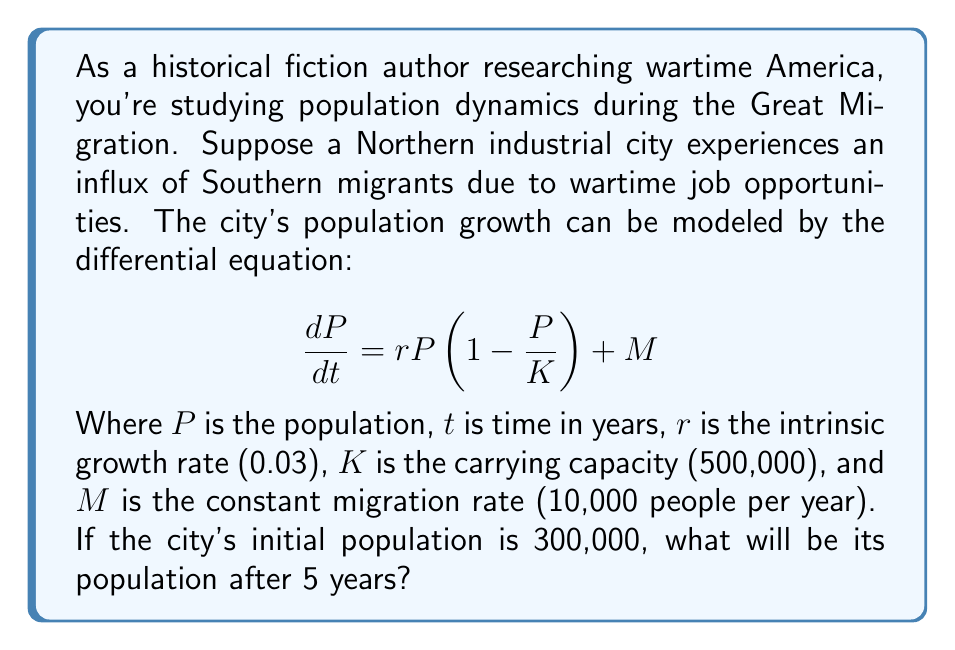Provide a solution to this math problem. To solve this problem, we need to use numerical methods, as the differential equation doesn't have a simple analytical solution. We'll use the Euler method with a small time step to approximate the population growth.

1. Set up the Euler method:
   $$P_{n+1} = P_n + \Delta t \cdot (\frac{dP}{dt})_n$$
   Where $\Delta t$ is the time step (we'll use 0.1 years for accuracy).

2. Expand the differential equation:
   $$\frac{dP}{dt} = 0.03P(1 - \frac{P}{500000}) + 10000$$

3. Initialize variables:
   $P_0 = 300000$
   $t = 0$
   $\Delta t = 0.1$

4. Iterate the Euler method for 5 years (50 steps):
   For each step $n$ from 0 to 49:
   $$P_{n+1} = P_n + 0.1 \cdot (0.03P_n(1 - \frac{P_n}{500000}) + 10000)$$

5. Implement the iteration (showing key steps):
   Step 0: $P_0 = 300000$
   Step 1: $P_1 = 300000 + 0.1 \cdot (0.03 \cdot 300000(1 - \frac{300000}{500000}) + 10000) = 301710$
   Step 2: $P_2 = 301710 + 0.1 \cdot (0.03 \cdot 301710(1 - \frac{301710}{500000}) + 10000) = 303411$
   ...
   Step 49: $P_{49} = 349428 + 0.1 \cdot (0.03 \cdot 349428(1 - \frac{349428}{500000}) + 10000) = 350891$
   Step 50: $P_{50} = 350891 + 0.1 \cdot (0.03 \cdot 350891(1 - \frac{350891}{500000}) + 10000) = 352347$

The final population after 5 years (50 steps) is approximately 352,347 people.
Answer: 352,347 people 